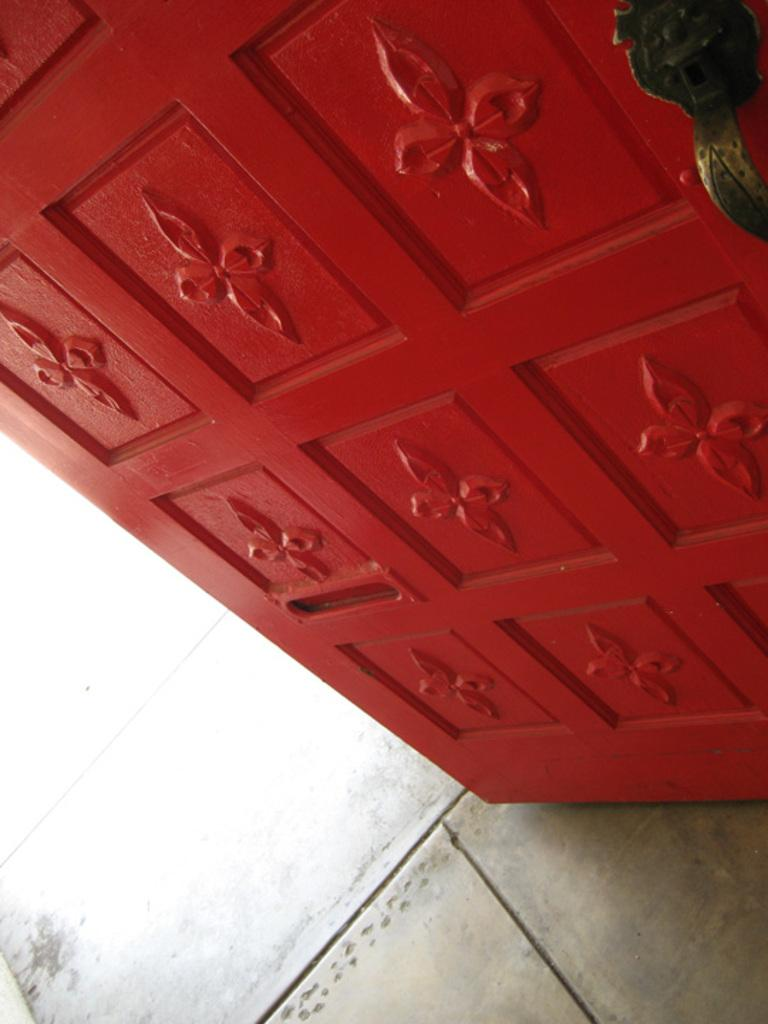What is the main object in the image? There is a door in the image. What type of property is the door attached to in the image? The provided facts do not mention any property or building associated with the door, so it cannot be determined from the image. Can you see a pen on the door in the image? There is no pen present on the door in the image. 